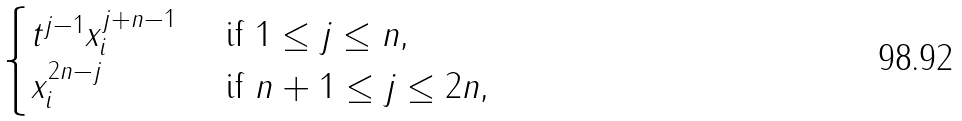Convert formula to latex. <formula><loc_0><loc_0><loc_500><loc_500>\begin{cases} t ^ { j - 1 } x _ { i } ^ { j + n - 1 } & \text { if $1\leq j\leq n$,} \\ x _ { i } ^ { 2 n - j } & \text { if $n+1\leq j\leq 2n$,} \\ \end{cases}</formula> 